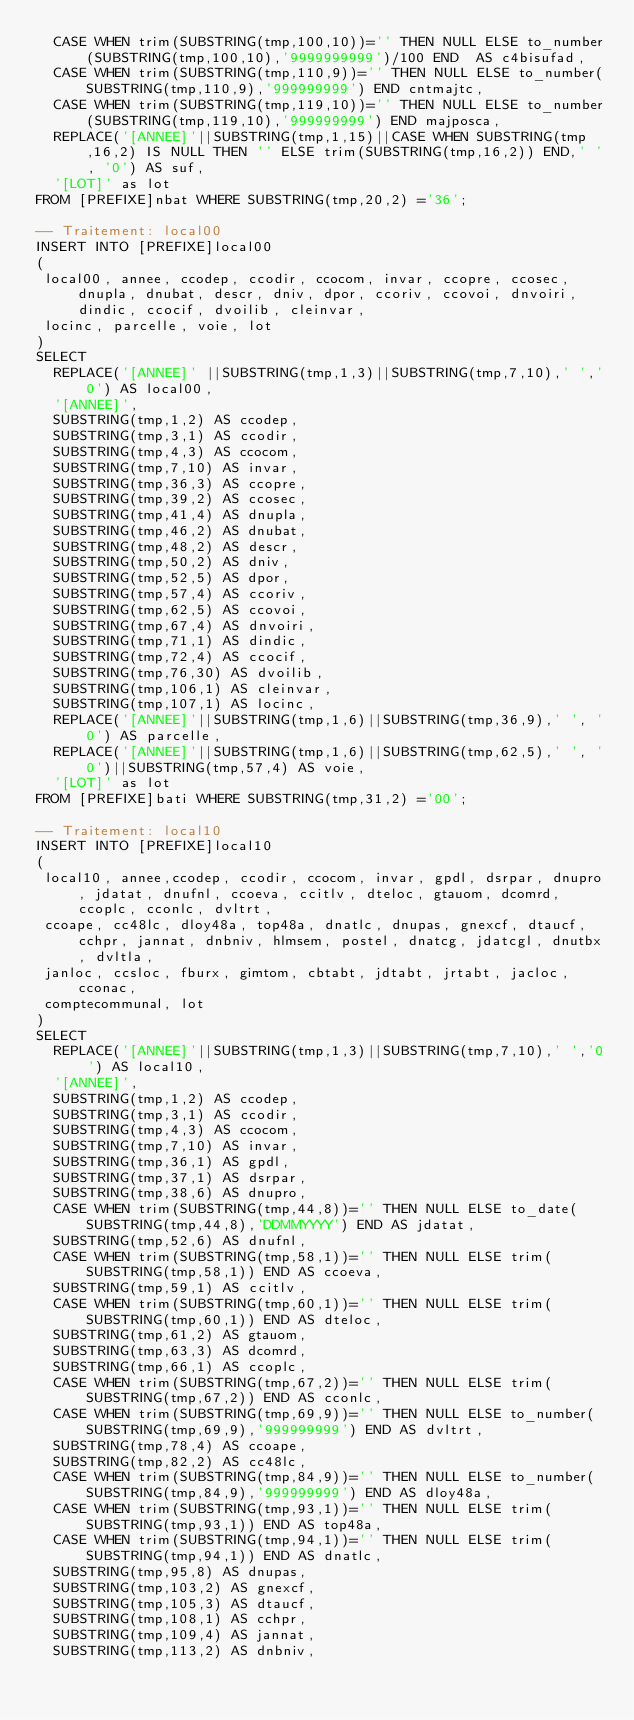Convert code to text. <code><loc_0><loc_0><loc_500><loc_500><_SQL_>  CASE WHEN trim(SUBSTRING(tmp,100,10))='' THEN NULL ELSE to_number(SUBSTRING(tmp,100,10),'9999999999')/100 END  AS c4bisufad,
  CASE WHEN trim(SUBSTRING(tmp,110,9))='' THEN NULL ELSE to_number(SUBSTRING(tmp,110,9),'999999999') END cntmajtc,
  CASE WHEN trim(SUBSTRING(tmp,119,10))='' THEN NULL ELSE to_number(SUBSTRING(tmp,119,10),'999999999') END majposca,
  REPLACE('[ANNEE]'||SUBSTRING(tmp,1,15)||CASE WHEN SUBSTRING(tmp,16,2) IS NULL THEN '' ELSE trim(SUBSTRING(tmp,16,2)) END,' ', '0') AS suf,
  '[LOT]' as lot
FROM [PREFIXE]nbat WHERE SUBSTRING(tmp,20,2) ='36';

-- Traitement: local00
INSERT INTO [PREFIXE]local00
(
 local00, annee, ccodep, ccodir, ccocom, invar, ccopre, ccosec, dnupla, dnubat, descr, dniv, dpor, ccoriv, ccovoi, dnvoiri, dindic, ccocif, dvoilib, cleinvar,
 locinc, parcelle, voie, lot
)
SELECT
  REPLACE('[ANNEE]' ||SUBSTRING(tmp,1,3)||SUBSTRING(tmp,7,10),' ','0') AS local00,
  '[ANNEE]',
  SUBSTRING(tmp,1,2) AS ccodep,
  SUBSTRING(tmp,3,1) AS ccodir,
  SUBSTRING(tmp,4,3) AS ccocom,
  SUBSTRING(tmp,7,10) AS invar,
  SUBSTRING(tmp,36,3) AS ccopre,
  SUBSTRING(tmp,39,2) AS ccosec,
  SUBSTRING(tmp,41,4) AS dnupla,
  SUBSTRING(tmp,46,2) AS dnubat,
  SUBSTRING(tmp,48,2) AS descr,
  SUBSTRING(tmp,50,2) AS dniv,
  SUBSTRING(tmp,52,5) AS dpor,
  SUBSTRING(tmp,57,4) AS ccoriv,
  SUBSTRING(tmp,62,5) AS ccovoi,
  SUBSTRING(tmp,67,4) AS dnvoiri,
  SUBSTRING(tmp,71,1) AS dindic,
  SUBSTRING(tmp,72,4) AS ccocif,
  SUBSTRING(tmp,76,30) AS dvoilib,
  SUBSTRING(tmp,106,1) AS cleinvar,
  SUBSTRING(tmp,107,1) AS locinc,
  REPLACE('[ANNEE]'||SUBSTRING(tmp,1,6)||SUBSTRING(tmp,36,9),' ', '0') AS parcelle,
  REPLACE('[ANNEE]'||SUBSTRING(tmp,1,6)||SUBSTRING(tmp,62,5),' ', '0')||SUBSTRING(tmp,57,4) AS voie,
  '[LOT]' as lot
FROM [PREFIXE]bati WHERE SUBSTRING(tmp,31,2) ='00';

-- Traitement: local10
INSERT INTO [PREFIXE]local10
(
 local10, annee,ccodep, ccodir, ccocom, invar, gpdl, dsrpar, dnupro, jdatat, dnufnl, ccoeva, ccitlv, dteloc, gtauom, dcomrd, ccoplc, cconlc, dvltrt,
 ccoape, cc48lc, dloy48a, top48a, dnatlc, dnupas, gnexcf, dtaucf, cchpr, jannat, dnbniv, hlmsem, postel, dnatcg, jdatcgl, dnutbx, dvltla,
 janloc, ccsloc, fburx, gimtom, cbtabt, jdtabt, jrtabt, jacloc, cconac,
 comptecommunal, lot
)
SELECT
  REPLACE('[ANNEE]'||SUBSTRING(tmp,1,3)||SUBSTRING(tmp,7,10),' ','0') AS local10,
  '[ANNEE]',
  SUBSTRING(tmp,1,2) AS ccodep,
  SUBSTRING(tmp,3,1) AS ccodir,
  SUBSTRING(tmp,4,3) AS ccocom,
  SUBSTRING(tmp,7,10) AS invar,
  SUBSTRING(tmp,36,1) AS gpdl,
  SUBSTRING(tmp,37,1) AS dsrpar,
  SUBSTRING(tmp,38,6) AS dnupro,
  CASE WHEN trim(SUBSTRING(tmp,44,8))='' THEN NULL ELSE to_date(SUBSTRING(tmp,44,8),'DDMMYYYY') END AS jdatat,
  SUBSTRING(tmp,52,6) AS dnufnl,
  CASE WHEN trim(SUBSTRING(tmp,58,1))='' THEN NULL ELSE trim(SUBSTRING(tmp,58,1)) END AS ccoeva,
  SUBSTRING(tmp,59,1) AS ccitlv,
  CASE WHEN trim(SUBSTRING(tmp,60,1))='' THEN NULL ELSE trim(SUBSTRING(tmp,60,1)) END AS dteloc,
  SUBSTRING(tmp,61,2) AS gtauom,
  SUBSTRING(tmp,63,3) AS dcomrd,
  SUBSTRING(tmp,66,1) AS ccoplc,
  CASE WHEN trim(SUBSTRING(tmp,67,2))='' THEN NULL ELSE trim(SUBSTRING(tmp,67,2)) END AS cconlc,
  CASE WHEN trim(SUBSTRING(tmp,69,9))='' THEN NULL ELSE to_number(SUBSTRING(tmp,69,9),'999999999') END AS dvltrt,
  SUBSTRING(tmp,78,4) AS ccoape,
  SUBSTRING(tmp,82,2) AS cc48lc,
  CASE WHEN trim(SUBSTRING(tmp,84,9))='' THEN NULL ELSE to_number(SUBSTRING(tmp,84,9),'999999999') END AS dloy48a,
  CASE WHEN trim(SUBSTRING(tmp,93,1))='' THEN NULL ELSE trim(SUBSTRING(tmp,93,1)) END AS top48a,
  CASE WHEN trim(SUBSTRING(tmp,94,1))='' THEN NULL ELSE trim(SUBSTRING(tmp,94,1)) END AS dnatlc,
  SUBSTRING(tmp,95,8) AS dnupas,
  SUBSTRING(tmp,103,2) AS gnexcf,
  SUBSTRING(tmp,105,3) AS dtaucf,
  SUBSTRING(tmp,108,1) AS cchpr,
  SUBSTRING(tmp,109,4) AS jannat,
  SUBSTRING(tmp,113,2) AS dnbniv,</code> 